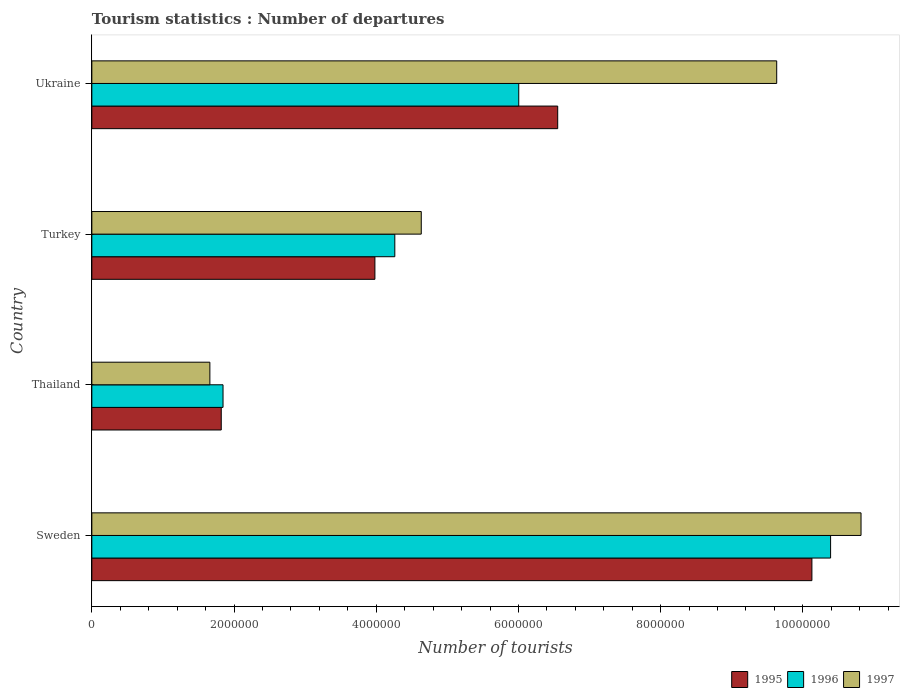How many different coloured bars are there?
Keep it short and to the point. 3. How many bars are there on the 2nd tick from the top?
Your answer should be compact. 3. In how many cases, is the number of bars for a given country not equal to the number of legend labels?
Ensure brevity in your answer.  0. What is the number of tourist departures in 1995 in Thailand?
Provide a short and direct response. 1.82e+06. Across all countries, what is the maximum number of tourist departures in 1997?
Make the answer very short. 1.08e+07. Across all countries, what is the minimum number of tourist departures in 1997?
Your response must be concise. 1.66e+06. In which country was the number of tourist departures in 1996 maximum?
Keep it short and to the point. Sweden. In which country was the number of tourist departures in 1995 minimum?
Keep it short and to the point. Thailand. What is the total number of tourist departures in 1996 in the graph?
Provide a succinct answer. 2.25e+07. What is the difference between the number of tourist departures in 1995 in Sweden and that in Ukraine?
Your answer should be very brief. 3.58e+06. What is the difference between the number of tourist departures in 1997 in Turkey and the number of tourist departures in 1996 in Sweden?
Give a very brief answer. -5.76e+06. What is the average number of tourist departures in 1995 per country?
Your answer should be very brief. 5.62e+06. What is the difference between the number of tourist departures in 1995 and number of tourist departures in 1996 in Thailand?
Your answer should be compact. -2.50e+04. In how many countries, is the number of tourist departures in 1997 greater than 6000000 ?
Offer a terse response. 2. What is the ratio of the number of tourist departures in 1996 in Sweden to that in Thailand?
Make the answer very short. 5.63. Is the number of tourist departures in 1995 in Sweden less than that in Ukraine?
Make the answer very short. No. Is the difference between the number of tourist departures in 1995 in Sweden and Thailand greater than the difference between the number of tourist departures in 1996 in Sweden and Thailand?
Give a very brief answer. No. What is the difference between the highest and the second highest number of tourist departures in 1996?
Give a very brief answer. 4.39e+06. What is the difference between the highest and the lowest number of tourist departures in 1997?
Your answer should be very brief. 9.16e+06. Is the sum of the number of tourist departures in 1997 in Turkey and Ukraine greater than the maximum number of tourist departures in 1995 across all countries?
Make the answer very short. Yes. What does the 2nd bar from the top in Thailand represents?
Provide a succinct answer. 1996. Is it the case that in every country, the sum of the number of tourist departures in 1997 and number of tourist departures in 1996 is greater than the number of tourist departures in 1995?
Provide a short and direct response. Yes. Are all the bars in the graph horizontal?
Provide a succinct answer. Yes. How many countries are there in the graph?
Your response must be concise. 4. Where does the legend appear in the graph?
Your response must be concise. Bottom right. How many legend labels are there?
Offer a terse response. 3. What is the title of the graph?
Your answer should be compact. Tourism statistics : Number of departures. Does "2010" appear as one of the legend labels in the graph?
Ensure brevity in your answer.  No. What is the label or title of the X-axis?
Make the answer very short. Number of tourists. What is the label or title of the Y-axis?
Make the answer very short. Country. What is the Number of tourists in 1995 in Sweden?
Your answer should be very brief. 1.01e+07. What is the Number of tourists of 1996 in Sweden?
Give a very brief answer. 1.04e+07. What is the Number of tourists in 1997 in Sweden?
Provide a succinct answer. 1.08e+07. What is the Number of tourists in 1995 in Thailand?
Ensure brevity in your answer.  1.82e+06. What is the Number of tourists of 1996 in Thailand?
Your response must be concise. 1.84e+06. What is the Number of tourists in 1997 in Thailand?
Provide a succinct answer. 1.66e+06. What is the Number of tourists of 1995 in Turkey?
Make the answer very short. 3.98e+06. What is the Number of tourists of 1996 in Turkey?
Ensure brevity in your answer.  4.26e+06. What is the Number of tourists of 1997 in Turkey?
Offer a terse response. 4.63e+06. What is the Number of tourists in 1995 in Ukraine?
Offer a terse response. 6.55e+06. What is the Number of tourists in 1996 in Ukraine?
Ensure brevity in your answer.  6.00e+06. What is the Number of tourists of 1997 in Ukraine?
Your answer should be very brief. 9.63e+06. Across all countries, what is the maximum Number of tourists of 1995?
Provide a succinct answer. 1.01e+07. Across all countries, what is the maximum Number of tourists in 1996?
Offer a terse response. 1.04e+07. Across all countries, what is the maximum Number of tourists in 1997?
Your response must be concise. 1.08e+07. Across all countries, what is the minimum Number of tourists of 1995?
Provide a succinct answer. 1.82e+06. Across all countries, what is the minimum Number of tourists of 1996?
Your response must be concise. 1.84e+06. Across all countries, what is the minimum Number of tourists of 1997?
Keep it short and to the point. 1.66e+06. What is the total Number of tourists in 1995 in the graph?
Your answer should be compact. 2.25e+07. What is the total Number of tourists of 1996 in the graph?
Your answer should be compact. 2.25e+07. What is the total Number of tourists of 1997 in the graph?
Your response must be concise. 2.67e+07. What is the difference between the Number of tourists in 1995 in Sweden and that in Thailand?
Offer a very short reply. 8.31e+06. What is the difference between the Number of tourists of 1996 in Sweden and that in Thailand?
Provide a short and direct response. 8.54e+06. What is the difference between the Number of tourists of 1997 in Sweden and that in Thailand?
Offer a very short reply. 9.16e+06. What is the difference between the Number of tourists of 1995 in Sweden and that in Turkey?
Provide a succinct answer. 6.15e+06. What is the difference between the Number of tourists of 1996 in Sweden and that in Turkey?
Offer a terse response. 6.13e+06. What is the difference between the Number of tourists of 1997 in Sweden and that in Turkey?
Your answer should be very brief. 6.18e+06. What is the difference between the Number of tourists of 1995 in Sweden and that in Ukraine?
Your response must be concise. 3.58e+06. What is the difference between the Number of tourists in 1996 in Sweden and that in Ukraine?
Give a very brief answer. 4.39e+06. What is the difference between the Number of tourists of 1997 in Sweden and that in Ukraine?
Offer a terse response. 1.19e+06. What is the difference between the Number of tourists of 1995 in Thailand and that in Turkey?
Your answer should be very brief. -2.16e+06. What is the difference between the Number of tourists in 1996 in Thailand and that in Turkey?
Your answer should be very brief. -2.42e+06. What is the difference between the Number of tourists in 1997 in Thailand and that in Turkey?
Ensure brevity in your answer.  -2.97e+06. What is the difference between the Number of tourists of 1995 in Thailand and that in Ukraine?
Give a very brief answer. -4.73e+06. What is the difference between the Number of tourists of 1996 in Thailand and that in Ukraine?
Ensure brevity in your answer.  -4.16e+06. What is the difference between the Number of tourists of 1997 in Thailand and that in Ukraine?
Keep it short and to the point. -7.97e+06. What is the difference between the Number of tourists of 1995 in Turkey and that in Ukraine?
Provide a succinct answer. -2.57e+06. What is the difference between the Number of tourists of 1996 in Turkey and that in Ukraine?
Provide a succinct answer. -1.74e+06. What is the difference between the Number of tourists of 1997 in Turkey and that in Ukraine?
Ensure brevity in your answer.  -5.00e+06. What is the difference between the Number of tourists in 1995 in Sweden and the Number of tourists in 1996 in Thailand?
Offer a very short reply. 8.28e+06. What is the difference between the Number of tourists of 1995 in Sweden and the Number of tourists of 1997 in Thailand?
Provide a short and direct response. 8.47e+06. What is the difference between the Number of tourists of 1996 in Sweden and the Number of tourists of 1997 in Thailand?
Your response must be concise. 8.73e+06. What is the difference between the Number of tourists in 1995 in Sweden and the Number of tourists in 1996 in Turkey?
Give a very brief answer. 5.87e+06. What is the difference between the Number of tourists of 1995 in Sweden and the Number of tourists of 1997 in Turkey?
Give a very brief answer. 5.49e+06. What is the difference between the Number of tourists of 1996 in Sweden and the Number of tourists of 1997 in Turkey?
Provide a succinct answer. 5.76e+06. What is the difference between the Number of tourists of 1995 in Sweden and the Number of tourists of 1996 in Ukraine?
Make the answer very short. 4.12e+06. What is the difference between the Number of tourists of 1995 in Sweden and the Number of tourists of 1997 in Ukraine?
Your answer should be very brief. 4.95e+05. What is the difference between the Number of tourists in 1996 in Sweden and the Number of tourists in 1997 in Ukraine?
Give a very brief answer. 7.58e+05. What is the difference between the Number of tourists in 1995 in Thailand and the Number of tourists in 1996 in Turkey?
Provide a short and direct response. -2.44e+06. What is the difference between the Number of tourists of 1995 in Thailand and the Number of tourists of 1997 in Turkey?
Provide a succinct answer. -2.81e+06. What is the difference between the Number of tourists of 1996 in Thailand and the Number of tourists of 1997 in Turkey?
Your response must be concise. -2.79e+06. What is the difference between the Number of tourists of 1995 in Thailand and the Number of tourists of 1996 in Ukraine?
Provide a succinct answer. -4.18e+06. What is the difference between the Number of tourists of 1995 in Thailand and the Number of tourists of 1997 in Ukraine?
Give a very brief answer. -7.81e+06. What is the difference between the Number of tourists in 1996 in Thailand and the Number of tourists in 1997 in Ukraine?
Provide a short and direct response. -7.79e+06. What is the difference between the Number of tourists of 1995 in Turkey and the Number of tourists of 1996 in Ukraine?
Your answer should be compact. -2.02e+06. What is the difference between the Number of tourists in 1995 in Turkey and the Number of tourists in 1997 in Ukraine?
Offer a terse response. -5.65e+06. What is the difference between the Number of tourists of 1996 in Turkey and the Number of tourists of 1997 in Ukraine?
Your response must be concise. -5.37e+06. What is the average Number of tourists in 1995 per country?
Your answer should be compact. 5.62e+06. What is the average Number of tourists of 1996 per country?
Offer a terse response. 5.62e+06. What is the average Number of tourists in 1997 per country?
Your answer should be very brief. 6.69e+06. What is the difference between the Number of tourists of 1995 and Number of tourists of 1996 in Sweden?
Your response must be concise. -2.63e+05. What is the difference between the Number of tourists of 1995 and Number of tourists of 1997 in Sweden?
Make the answer very short. -6.91e+05. What is the difference between the Number of tourists of 1996 and Number of tourists of 1997 in Sweden?
Provide a short and direct response. -4.28e+05. What is the difference between the Number of tourists in 1995 and Number of tourists in 1996 in Thailand?
Your response must be concise. -2.50e+04. What is the difference between the Number of tourists of 1996 and Number of tourists of 1997 in Thailand?
Keep it short and to the point. 1.85e+05. What is the difference between the Number of tourists in 1995 and Number of tourists in 1996 in Turkey?
Provide a short and direct response. -2.80e+05. What is the difference between the Number of tourists in 1995 and Number of tourists in 1997 in Turkey?
Your answer should be very brief. -6.52e+05. What is the difference between the Number of tourists of 1996 and Number of tourists of 1997 in Turkey?
Offer a terse response. -3.72e+05. What is the difference between the Number of tourists of 1995 and Number of tourists of 1996 in Ukraine?
Make the answer very short. 5.48e+05. What is the difference between the Number of tourists in 1995 and Number of tourists in 1997 in Ukraine?
Make the answer very short. -3.08e+06. What is the difference between the Number of tourists in 1996 and Number of tourists in 1997 in Ukraine?
Your answer should be compact. -3.63e+06. What is the ratio of the Number of tourists of 1995 in Sweden to that in Thailand?
Give a very brief answer. 5.56. What is the ratio of the Number of tourists of 1996 in Sweden to that in Thailand?
Give a very brief answer. 5.63. What is the ratio of the Number of tourists in 1997 in Sweden to that in Thailand?
Make the answer very short. 6.52. What is the ratio of the Number of tourists of 1995 in Sweden to that in Turkey?
Your answer should be very brief. 2.54. What is the ratio of the Number of tourists of 1996 in Sweden to that in Turkey?
Your response must be concise. 2.44. What is the ratio of the Number of tourists in 1997 in Sweden to that in Turkey?
Your answer should be very brief. 2.33. What is the ratio of the Number of tourists in 1995 in Sweden to that in Ukraine?
Provide a short and direct response. 1.55. What is the ratio of the Number of tourists of 1996 in Sweden to that in Ukraine?
Keep it short and to the point. 1.73. What is the ratio of the Number of tourists in 1997 in Sweden to that in Ukraine?
Provide a short and direct response. 1.12. What is the ratio of the Number of tourists of 1995 in Thailand to that in Turkey?
Your answer should be compact. 0.46. What is the ratio of the Number of tourists of 1996 in Thailand to that in Turkey?
Offer a terse response. 0.43. What is the ratio of the Number of tourists of 1997 in Thailand to that in Turkey?
Your answer should be compact. 0.36. What is the ratio of the Number of tourists of 1995 in Thailand to that in Ukraine?
Make the answer very short. 0.28. What is the ratio of the Number of tourists in 1996 in Thailand to that in Ukraine?
Provide a succinct answer. 0.31. What is the ratio of the Number of tourists in 1997 in Thailand to that in Ukraine?
Your answer should be very brief. 0.17. What is the ratio of the Number of tourists of 1995 in Turkey to that in Ukraine?
Provide a succinct answer. 0.61. What is the ratio of the Number of tourists in 1996 in Turkey to that in Ukraine?
Offer a terse response. 0.71. What is the ratio of the Number of tourists of 1997 in Turkey to that in Ukraine?
Your answer should be very brief. 0.48. What is the difference between the highest and the second highest Number of tourists in 1995?
Offer a terse response. 3.58e+06. What is the difference between the highest and the second highest Number of tourists in 1996?
Keep it short and to the point. 4.39e+06. What is the difference between the highest and the second highest Number of tourists in 1997?
Provide a short and direct response. 1.19e+06. What is the difference between the highest and the lowest Number of tourists in 1995?
Your answer should be very brief. 8.31e+06. What is the difference between the highest and the lowest Number of tourists of 1996?
Offer a very short reply. 8.54e+06. What is the difference between the highest and the lowest Number of tourists of 1997?
Offer a terse response. 9.16e+06. 